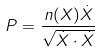<formula> <loc_0><loc_0><loc_500><loc_500>P = \frac { n ( X ) \dot { X } } { \sqrt { \dot { X } \cdot \dot { X } } }</formula> 